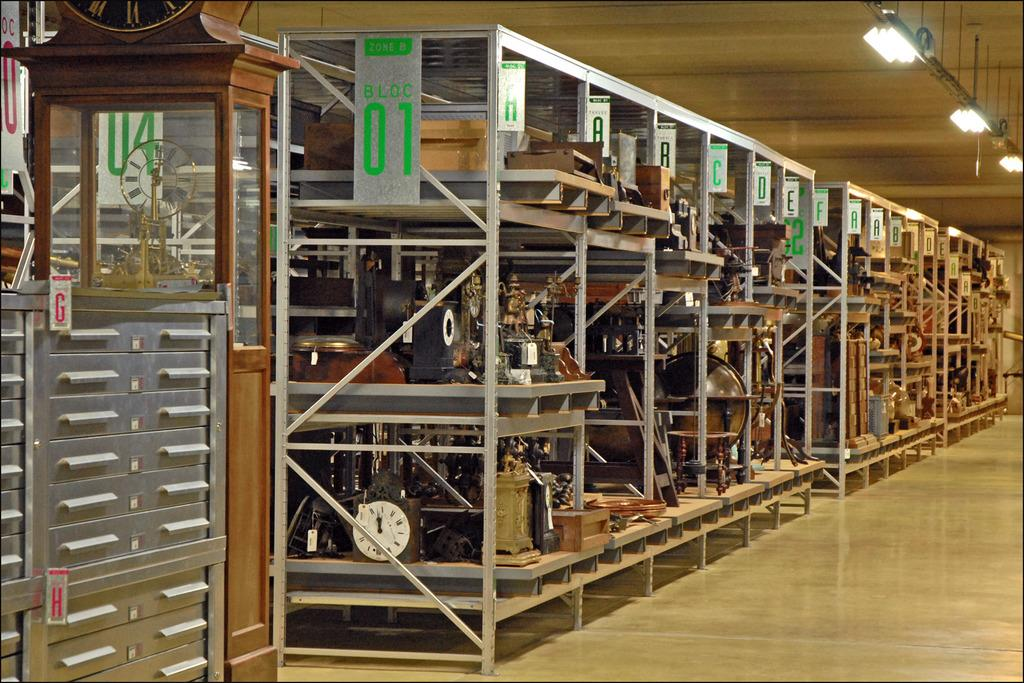<image>
Summarize the visual content of the image. Different products are on metal shelves in bloc 01. 